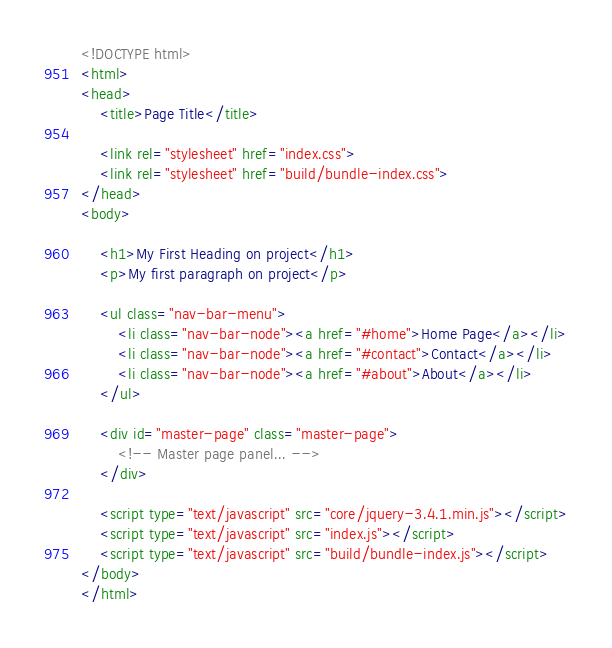<code> <loc_0><loc_0><loc_500><loc_500><_HTML_><!DOCTYPE html>
<html>
<head>
    <title>Page Title</title>

    <link rel="stylesheet" href="index.css">
    <link rel="stylesheet" href="build/bundle-index.css">
</head>
<body>

    <h1>My First Heading on project</h1>
    <p>My first paragraph on project</p>

    <ul class="nav-bar-menu">
        <li class="nav-bar-node"><a href="#home">Home Page</a></li>
        <li class="nav-bar-node"><a href="#contact">Contact</a></li>
        <li class="nav-bar-node"><a href="#about">About</a></li>
    </ul>

    <div id="master-page" class="master-page">
        <!-- Master page panel... -->
    </div>

    <script type="text/javascript" src="core/jquery-3.4.1.min.js"></script>
    <script type="text/javascript" src="index.js"></script>
    <script type="text/javascript" src="build/bundle-index.js"></script>
</body>
</html></code> 